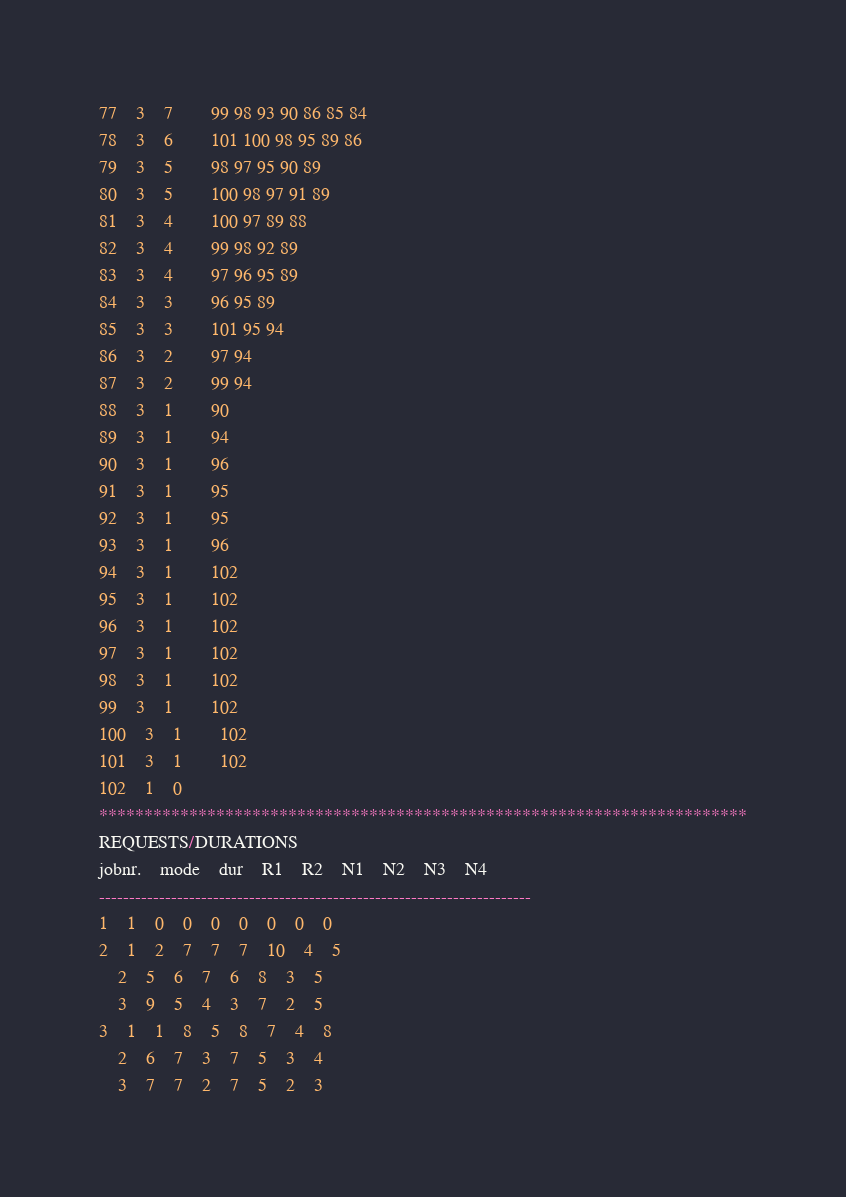<code> <loc_0><loc_0><loc_500><loc_500><_ObjectiveC_>77	3	7		99 98 93 90 86 85 84 
78	3	6		101 100 98 95 89 86 
79	3	5		98 97 95 90 89 
80	3	5		100 98 97 91 89 
81	3	4		100 97 89 88 
82	3	4		99 98 92 89 
83	3	4		97 96 95 89 
84	3	3		96 95 89 
85	3	3		101 95 94 
86	3	2		97 94 
87	3	2		99 94 
88	3	1		90 
89	3	1		94 
90	3	1		96 
91	3	1		95 
92	3	1		95 
93	3	1		96 
94	3	1		102 
95	3	1		102 
96	3	1		102 
97	3	1		102 
98	3	1		102 
99	3	1		102 
100	3	1		102 
101	3	1		102 
102	1	0		
************************************************************************
REQUESTS/DURATIONS
jobnr.	mode	dur	R1	R2	N1	N2	N3	N4	
------------------------------------------------------------------------
1	1	0	0	0	0	0	0	0	
2	1	2	7	7	7	10	4	5	
	2	5	6	7	6	8	3	5	
	3	9	5	4	3	7	2	5	
3	1	1	8	5	8	7	4	8	
	2	6	7	3	7	5	3	4	
	3	7	7	2	7	5	2	3	</code> 